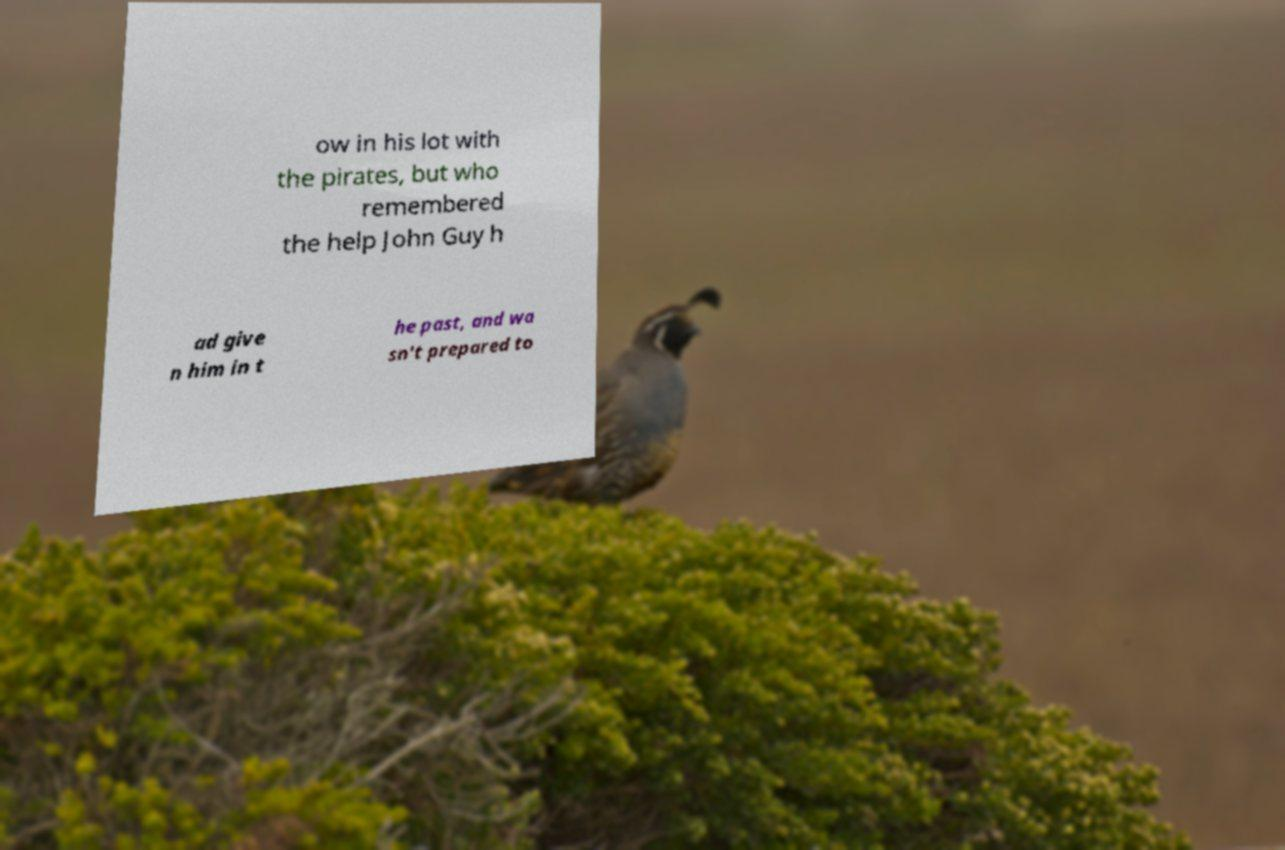Please identify and transcribe the text found in this image. ow in his lot with the pirates, but who remembered the help John Guy h ad give n him in t he past, and wa sn't prepared to 